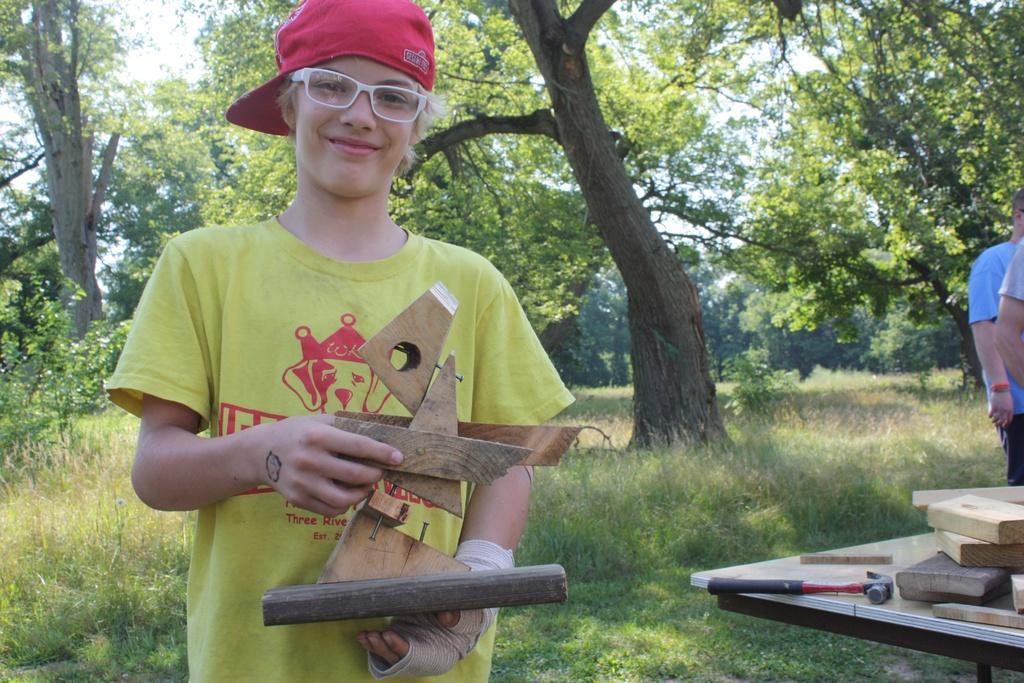Can you describe this image briefly? In this image we can see a boy wearing specs and cap. He is holding something in the hand. On the right side there is a table. On that there are wooden pieces and a hammer. Also there are two persons. On the ground there are plants and grass. In the background there are trees. 